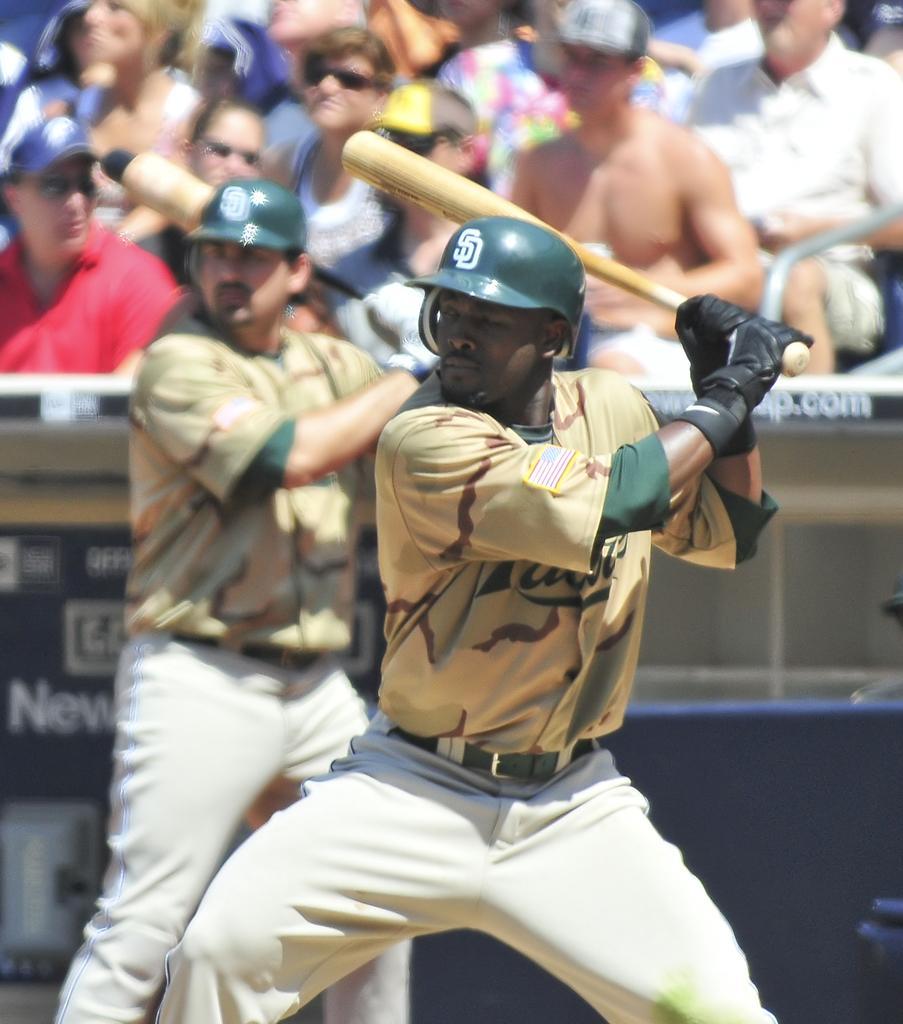How would you summarize this image in a sentence or two? In this picture there is a batsman who is wearing helmet, gloves, t-shirt and trouser. He is holding the base bat. At the back we can see another player who is also holding the base bat. At the top we can see the audience were watching the game. On the top right corner there is an old man who is wearing white shirt and short. He is sitting on the chair. 